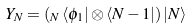<formula> <loc_0><loc_0><loc_500><loc_500>Y _ { N } = \left ( _ { N } \, \langle \phi _ { 1 } | \otimes \langle N - 1 | \right ) | N \rangle</formula> 